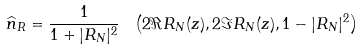Convert formula to latex. <formula><loc_0><loc_0><loc_500><loc_500>\widehat { n } _ { R } = \frac { 1 } { 1 + | R _ { N } | ^ { 2 } } \ \left ( 2 \Re R _ { N } ( z ) , 2 \Im R _ { N } ( z ) , 1 - | R _ { N } | ^ { 2 } \right )</formula> 